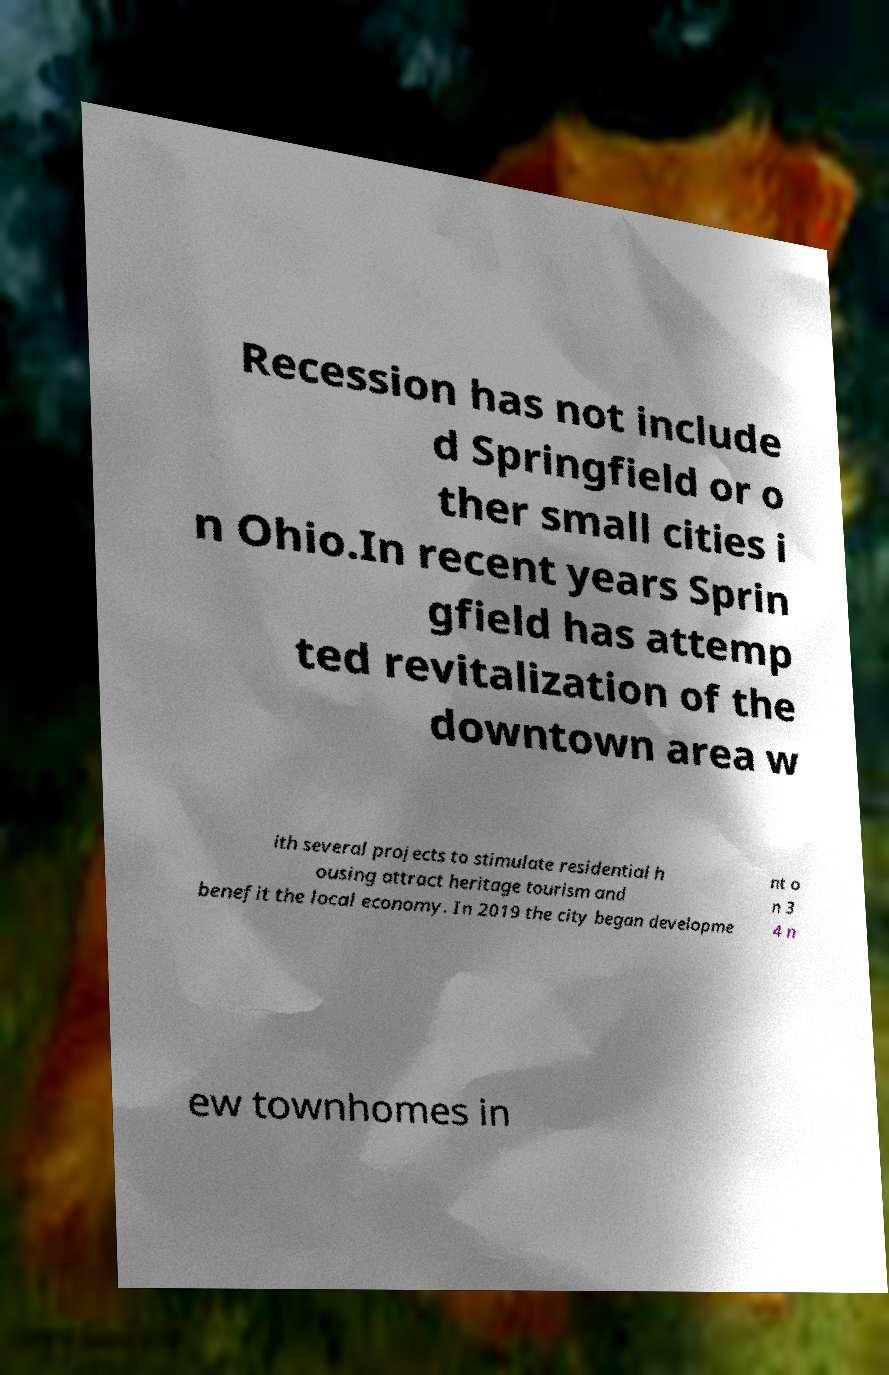Could you assist in decoding the text presented in this image and type it out clearly? Recession has not include d Springfield or o ther small cities i n Ohio.In recent years Sprin gfield has attemp ted revitalization of the downtown area w ith several projects to stimulate residential h ousing attract heritage tourism and benefit the local economy. In 2019 the city began developme nt o n 3 4 n ew townhomes in 